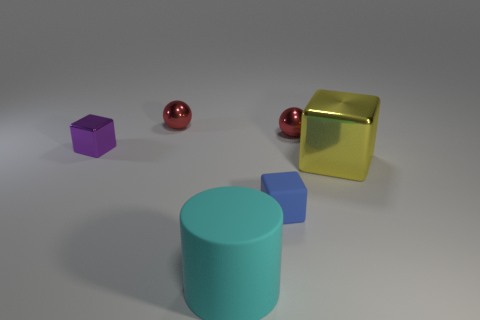Can you describe the lighting in the scene and how it affects the appearance of the objects? The lighting in the scene is diffused, coming from an overhead source. It softly illuminates the objects, creating gentle shadows on the ground. The highlights on the objects, especially the metallic spheres, indicate a single, strong light source. How would the objects' appearance change if they were placed in natural sunlight? In natural sunlight, the objects would have more pronounced shadows and highlights due to the sun's directional nature. The metallic objects would reflect the light more intensely, and the true colors of the matte surfaces would be more evident. 